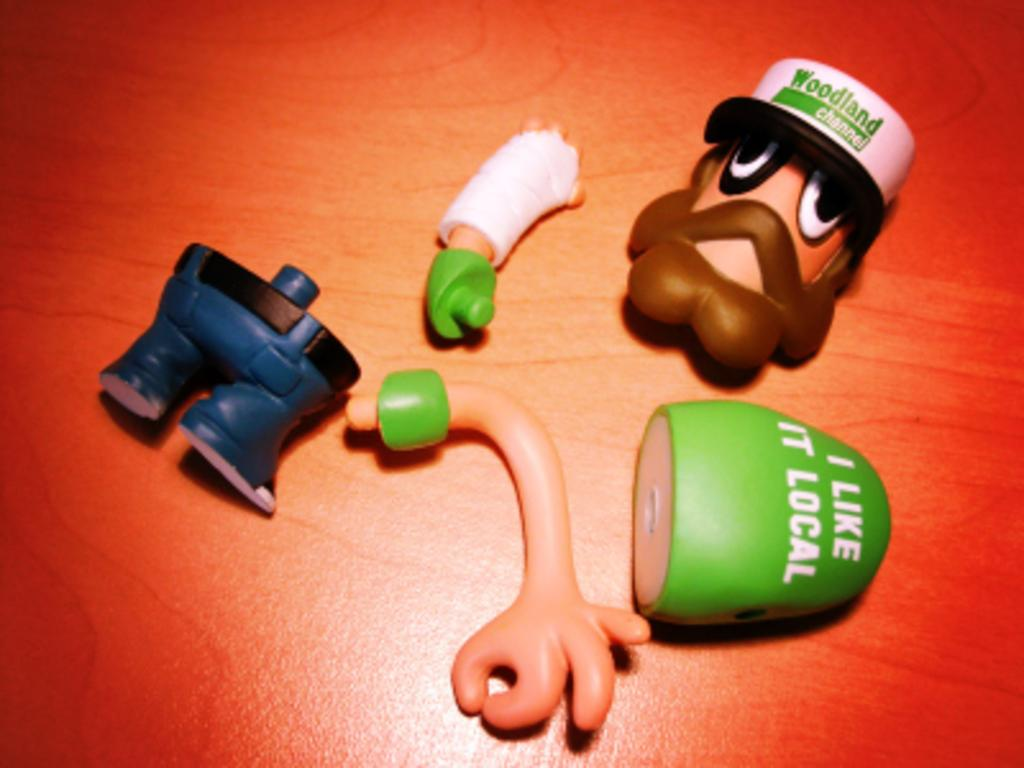What objects are on the table in the image? There are toys on the table in the image. What type of apple is being used as a channel for the aftermath of the toy explosion? There is no apple, channel, or toy explosion present in the image. 